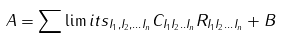Convert formula to latex. <formula><loc_0><loc_0><loc_500><loc_500>A = \sum \lim i t s _ { I _ { 1 } , I _ { 2 } , \dots I _ { n } } C _ { I _ { 1 } I _ { 2 } . . I _ { n } } R _ { I _ { 1 } I _ { 2 } \dots I _ { n } } + B</formula> 